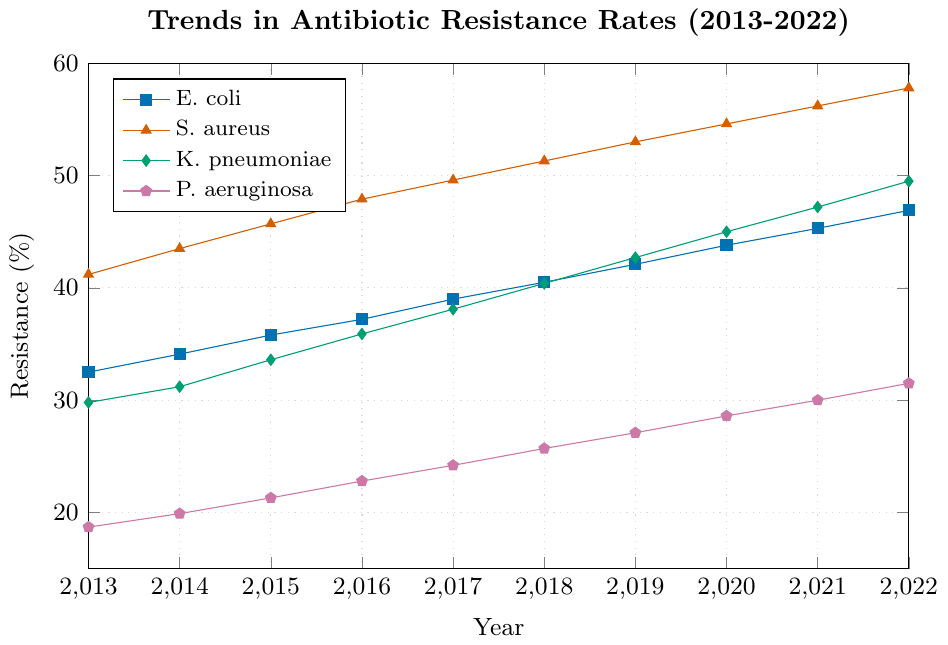What's the trend in the resistance rate of E. coli from 2013 to 2022? To identify the trend in the resistance rate of E. coli, examine its line in the figure. Over the years 2013-2022, the resistance rate for E. coli consistently increased from 32.5% to 46.9%.
Answer: Increased Which bacterial infection had the highest resistance rate in 2022? Look at the data points for the year 2022 and compare the resistance rates for all bacterial infections. The resistance rate for S. aureus was the highest at 57.8%.
Answer: S. aureus Did any bacterial infection show a decrease in resistance over the years? Review the lines representing each bacterial infection's resistance rate from 2013 to 2022. All lines show an upward trend, indicating that none of the bacterial infections exhibited a decrease in resistance rates.
Answer: No How much did the resistance rate of P. aeruginosa increase from 2013 to 2022? To find the increase, subtract the resistance rate of P. aeruginosa in 2013 (18.7%) from its resistance rate in 2022 (31.5%). The increase is 31.5% - 18.7% = 12.8%.
Answer: 12.8% Which year had the highest increase in resistance rate for S. aureus compared to the previous year? Evaluate the year-to-year differences in resistance rates for S. aureus. The highest increase occurred between 2020 to 2021, rising from 54.6% to 56.2%, an increase of 1.6%.
Answer: 2020 to 2021 Compare the resistance rates of K. pneumoniae and E. coli in 2015. Which one is higher and by how much? In 2015, K. pneumoniae had a resistance rate of 33.6% and E. coli had a resistance rate of 35.8%. The difference is 35.8% - 33.6% = 2.2%. E. coli's rate was higher by 2.2%.
Answer: E. coli by 2.2% What is the average resistance rate of S. aureus over the entire period? Sum up the resistance rates for S. aureus across the years, then divide by the number of years (10): (41.2 + 43.5 + 45.7 + 47.9 + 49.6 + 51.3 + 53.0 + 54.6 + 56.2 + 57.8) / 10 = 50.08%.
Answer: 50.08% Among the four bacteria, which had the lowest resistance rate in 2019? Observe the resistance rates for all bacteria in 2019. P. aeruginosa had the lowest resistance rate at 27.1%.
Answer: P. aeruginosa Did the resistance rates of K. pneumoniae ever surpass that of S. aureus from 2013 to 2022? Compare the resistance rates of K. pneumoniae and S. aureus for all the years from 2013 to 2022. K. pneumoniae's resistance rates consistently remained below those of S. aureus.
Answer: No What is the median resistance rate of E. coli for the given time period? The sorted resistance rates of E. coli are: 32.5, 34.1, 35.8, 37.2, 39.0, 40.5, 42.1, 43.8, 45.3, 46.9. The median is the middle value, so median is the average of the 5th and 6th values: (39.0 + 40.5) / 2 = 39.75%.
Answer: 39.75% 